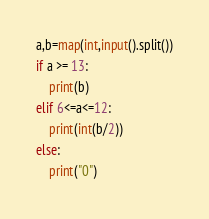Convert code to text. <code><loc_0><loc_0><loc_500><loc_500><_Python_>a,b=map(int,input().split())
if a >= 13:
    print(b)
elif 6<=a<=12:
    print(int(b/2))
else:
    print("0")</code> 